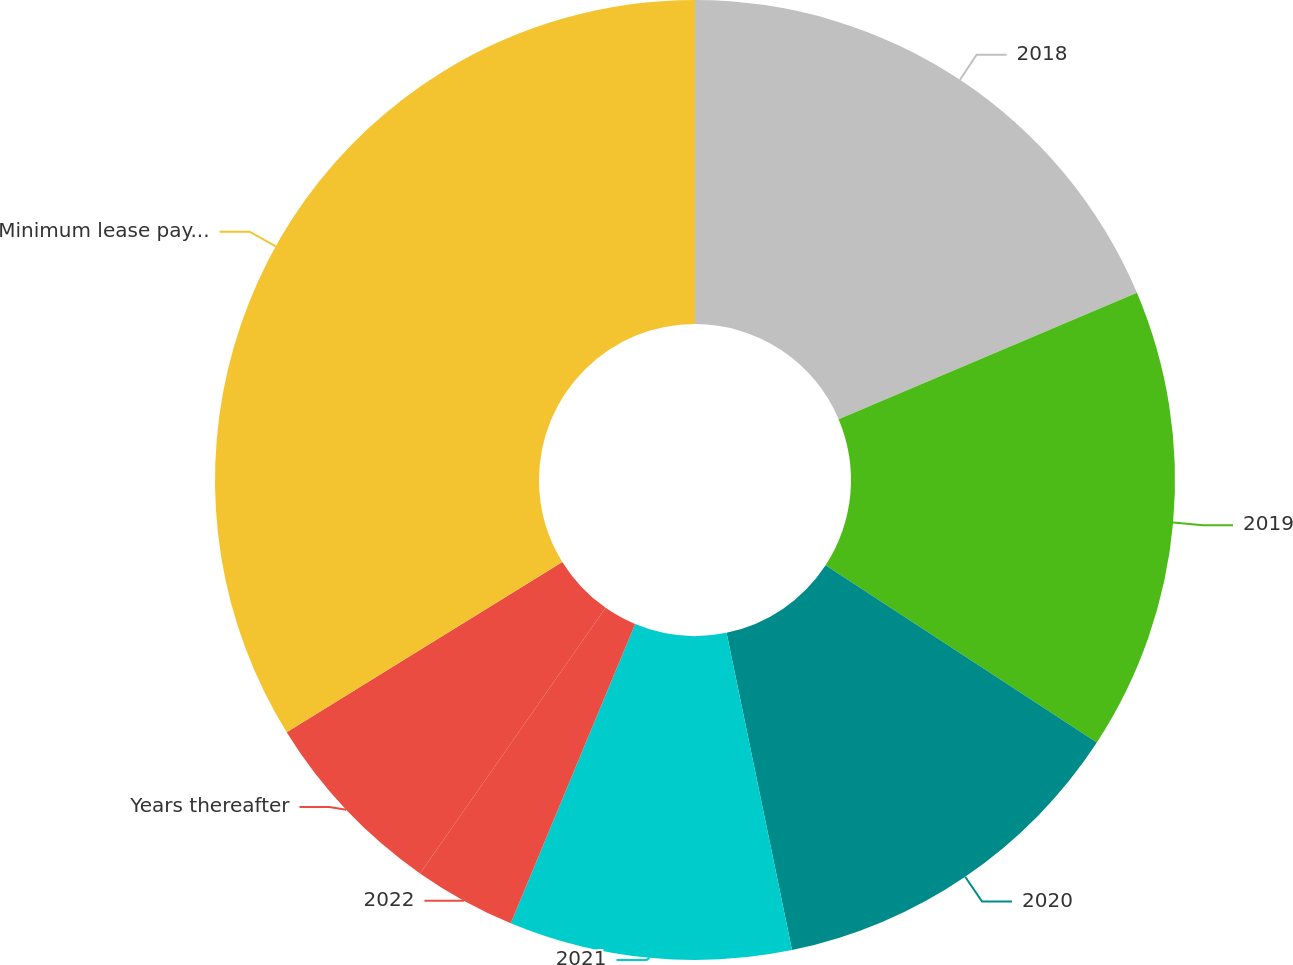Convert chart. <chart><loc_0><loc_0><loc_500><loc_500><pie_chart><fcel>2018<fcel>2019<fcel>2020<fcel>2021<fcel>2022<fcel>Years thereafter<fcel>Minimum lease payments<nl><fcel>18.62%<fcel>15.59%<fcel>12.55%<fcel>9.51%<fcel>3.44%<fcel>6.48%<fcel>33.81%<nl></chart> 